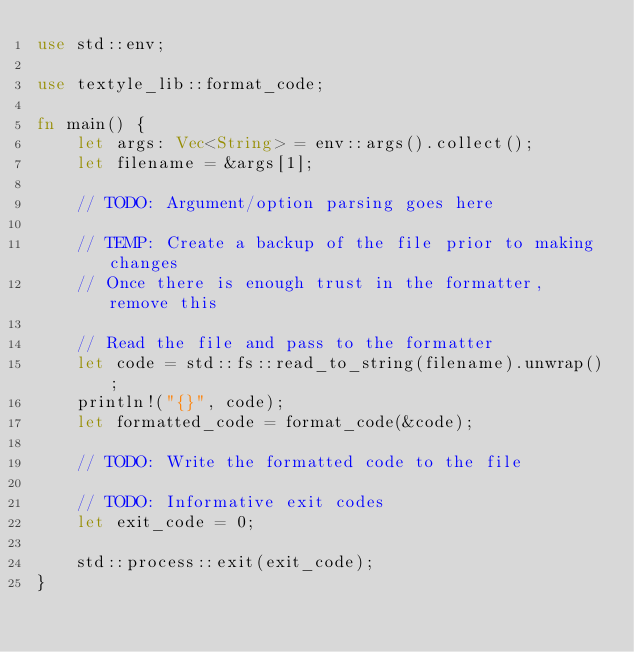<code> <loc_0><loc_0><loc_500><loc_500><_Rust_>use std::env;

use textyle_lib::format_code;

fn main() {
    let args: Vec<String> = env::args().collect();
    let filename = &args[1];

    // TODO: Argument/option parsing goes here

    // TEMP: Create a backup of the file prior to making changes
    // Once there is enough trust in the formatter, remove this

    // Read the file and pass to the formatter
    let code = std::fs::read_to_string(filename).unwrap();
    println!("{}", code);
    let formatted_code = format_code(&code);

    // TODO: Write the formatted code to the file

    // TODO: Informative exit codes
    let exit_code = 0;

    std::process::exit(exit_code);
}
</code> 